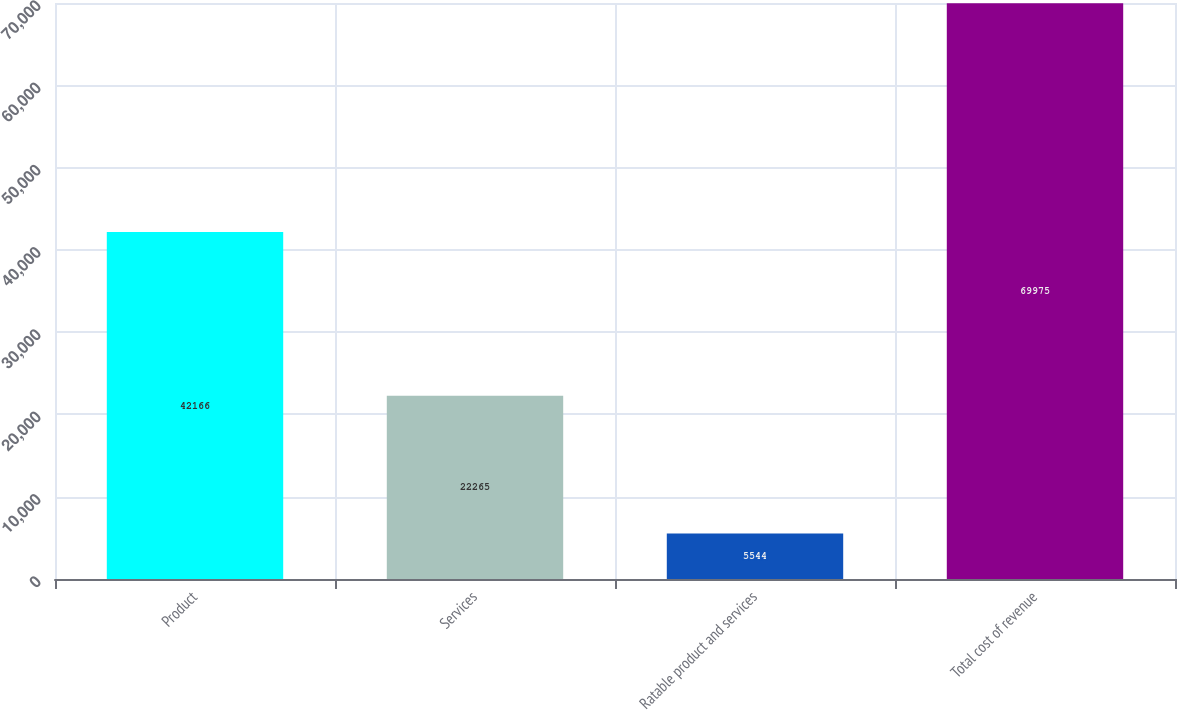Convert chart. <chart><loc_0><loc_0><loc_500><loc_500><bar_chart><fcel>Product<fcel>Services<fcel>Ratable product and services<fcel>Total cost of revenue<nl><fcel>42166<fcel>22265<fcel>5544<fcel>69975<nl></chart> 